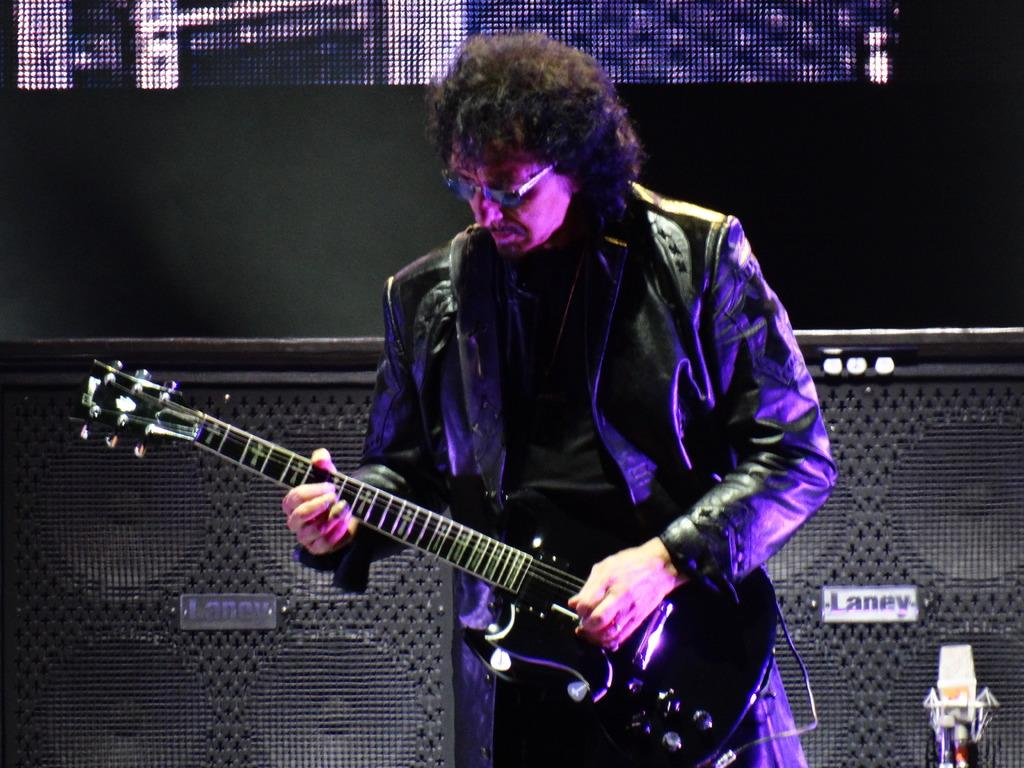Who is present in the image? There is a man in the image. What is the man wearing? The man is wearing a jacket. What is the man holding in the image? The man is holding a guitar. What can be seen in the background of the image? There are speakers visible in the background of the image. What type of food is the man eating in the image? There is no food present in the image; the man is holding a guitar. How does the man's sock contribute to the overall composition of the image? There is no mention of a sock in the image, so it cannot contribute to the composition. 